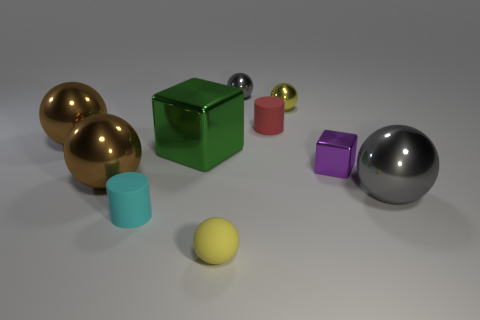Subtract all yellow balls. How many balls are left? 4 Subtract all tiny yellow balls. How many balls are left? 4 Subtract all green balls. Subtract all blue cylinders. How many balls are left? 6 Subtract all cylinders. How many objects are left? 8 Add 4 tiny yellow matte things. How many tiny yellow matte things are left? 5 Add 8 yellow spheres. How many yellow spheres exist? 10 Subtract 0 blue cubes. How many objects are left? 10 Subtract all large purple metal cubes. Subtract all purple cubes. How many objects are left? 9 